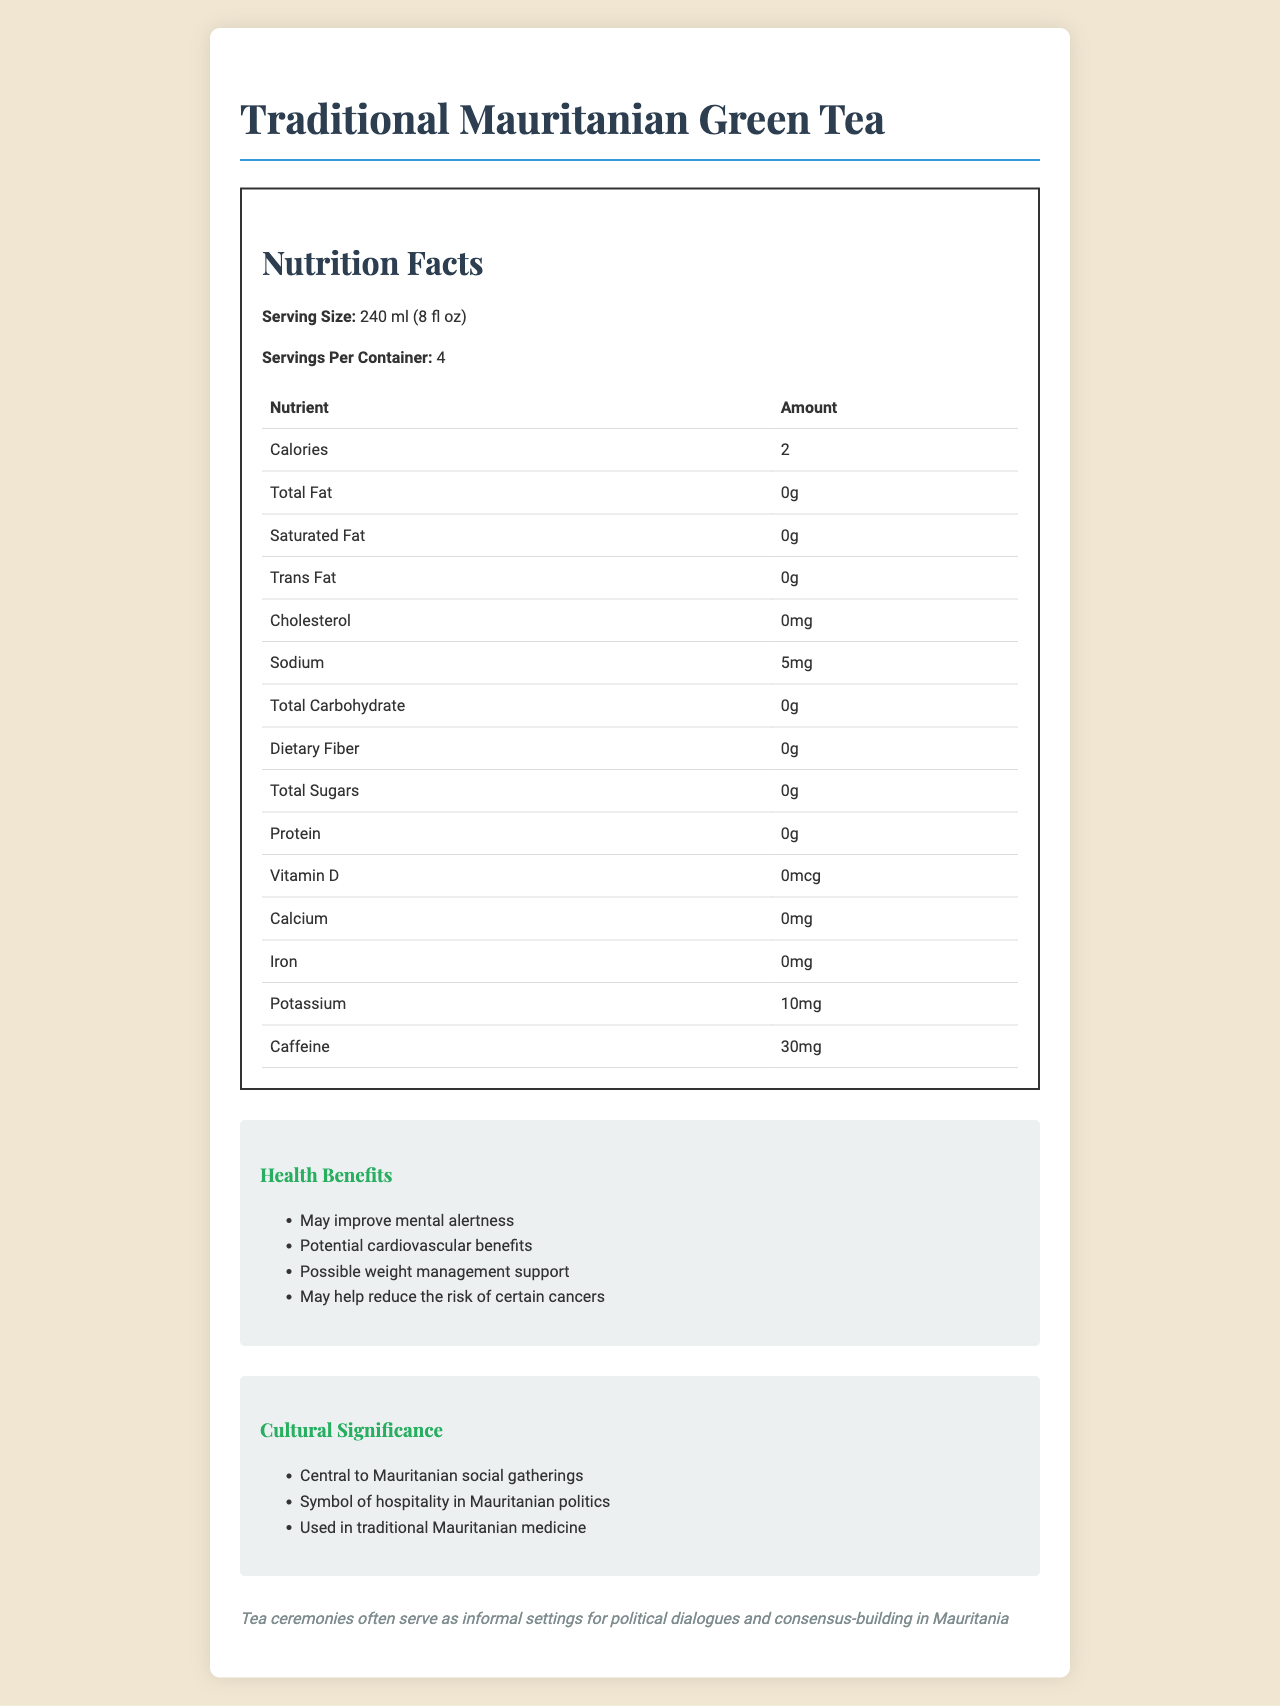What is the calories per serving of Traditional Mauritanian Green Tea? The document states that the calories per serving are 2.
Answer: 2 How many servings are there per container? The document mentions that there are 4 servings per container.
Answer: 4 What is the amount of sodium per serving? The sodium content per serving is specified as 5 mg.
Answer: 5 mg How much caffeine is in one serving of Traditional Mauritanian Green Tea? The document lists the caffeine content per serving as 30 mg.
Answer: 30 mg What potential health benefit is associated with mental alertness? The health benefits section mentions that the tea may improve mental alertness.
Answer: May improve mental alertness Which region of Mauritania prefers a stronger brew with less sugar? A. Nouakchott B. Adrar C. Tiris Zemmour The document indicates that Tiris Zemmour prefers a stronger brew with less sugar.
Answer: C What is used to brew Traditional Mauritanian Green Tea? A. Gunpowder green tea leaves B. Fresh mint C. Sugar D. All of the above The preparation method involves gunpowder green tea leaves, fresh mint, and sugar, making D the correct answer.
Answer: D How does the document describe the cultural significance of the tea in Mauritanian politics? A. Central to social gatherings B. Symbol of hospitality C. Used in traditional medicine The document highlights that the tea is a symbol of hospitality in Mauritanian politics.
Answer: B Is Traditional Mauritanian Green Tea considered to have any cardiovascular benefits? One of the document's listed health benefits is "Potential cardiovascular benefits."
Answer: Yes Please summarize the main idea of the document. The document includes detailed nutritional facts such as calories, caffeine content, and antioxidants. It also mentions various health benefits, the cultural importance of the tea in social and political contexts, and its role in traditional medicine.
Answer: The document provides detailed nutritional information and health benefits of Traditional Mauritanian Green Tea, along with its cultural significance, preparation methods, and regional variations in Mauritania. What is the exact amount of protein in one serving of Traditional Mauritanian Green Tea? The document shows that there is 0 grams of protein per serving.
Answer: 0 g What are the antioxidant components present in the tea? The document specifies that the tea contains 50 mg of catechins and 30 mg of flavonoids as antioxidants.
Answer: Catechins, Flavonoids What is the serving size of the tea in milliliters? The serving size is listed as 240 ml (8 fl oz).
Answer: 240 ml Who are most likely to consume this tea throughout the day? A. Farmers B. Politicians C. Students D. Athletes The document mentions that the tea is typically consumed throughout the day, especially during political discussions and negotiations.
Answer: B Given the nutritional information, can the tea be considered a significant source of calcium? The document lists the calcium content as 0 mg, indicating it is not a significant source.
Answer: No How does the consumption in Nouakchott differ from other regions? The document states that tea in Nouakchott has a higher sugar content compared to other regions.
Answer: Higher sugar content What is not listed as a mineral in the tea? The document lists manganese and fluoride as minerals but does not mention magnesium.
Answer: Magnesium What economic impact does Traditional Mauritanian Green Tea have? The economic impact section states that the tea is a significant contributor to local tea markets and the import economy.
Answer: Significant contributor to local tea markets and import economy 